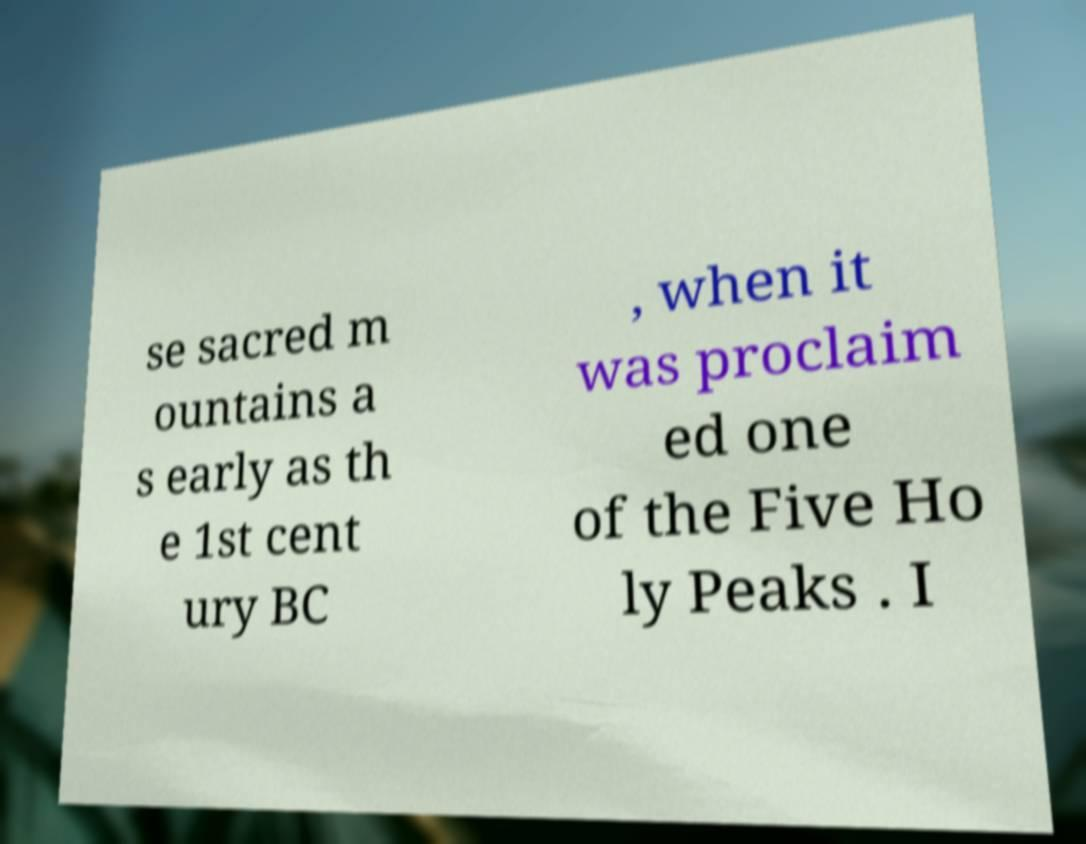There's text embedded in this image that I need extracted. Can you transcribe it verbatim? se sacred m ountains a s early as th e 1st cent ury BC , when it was proclaim ed one of the Five Ho ly Peaks . I 